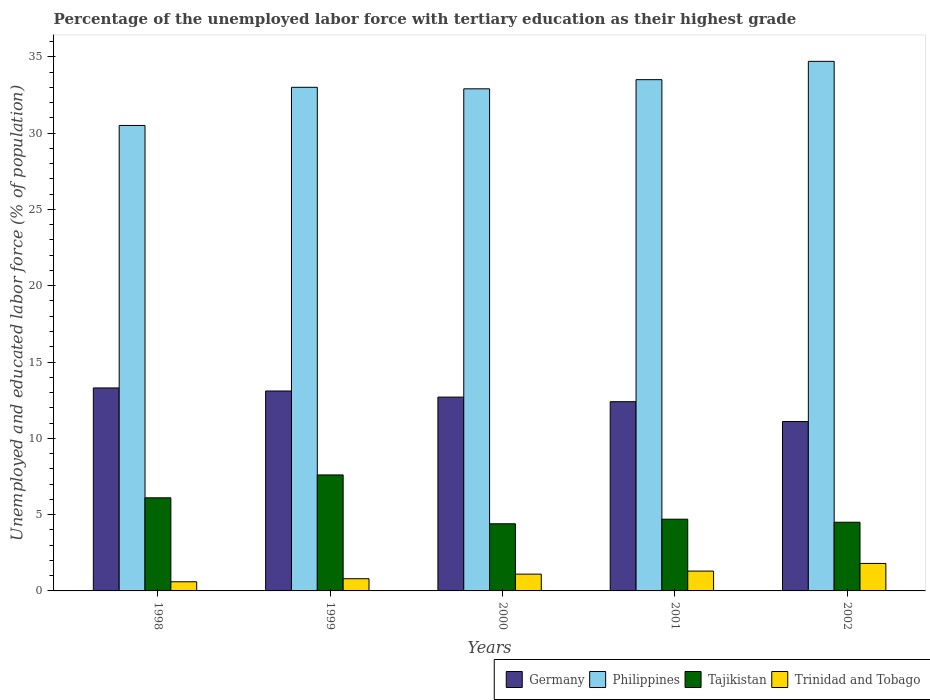How many different coloured bars are there?
Offer a very short reply. 4. How many groups of bars are there?
Your response must be concise. 5. How many bars are there on the 3rd tick from the left?
Provide a short and direct response. 4. What is the percentage of the unemployed labor force with tertiary education in Philippines in 2002?
Your response must be concise. 34.7. Across all years, what is the maximum percentage of the unemployed labor force with tertiary education in Trinidad and Tobago?
Offer a terse response. 1.8. Across all years, what is the minimum percentage of the unemployed labor force with tertiary education in Germany?
Offer a terse response. 11.1. In which year was the percentage of the unemployed labor force with tertiary education in Trinidad and Tobago maximum?
Keep it short and to the point. 2002. What is the total percentage of the unemployed labor force with tertiary education in Philippines in the graph?
Give a very brief answer. 164.6. What is the difference between the percentage of the unemployed labor force with tertiary education in Tajikistan in 1998 and that in 2002?
Give a very brief answer. 1.6. What is the difference between the percentage of the unemployed labor force with tertiary education in Philippines in 1998 and the percentage of the unemployed labor force with tertiary education in Germany in 1999?
Offer a very short reply. 17.4. What is the average percentage of the unemployed labor force with tertiary education in Philippines per year?
Your answer should be compact. 32.92. In the year 2000, what is the difference between the percentage of the unemployed labor force with tertiary education in Trinidad and Tobago and percentage of the unemployed labor force with tertiary education in Germany?
Give a very brief answer. -11.6. What is the ratio of the percentage of the unemployed labor force with tertiary education in Germany in 2001 to that in 2002?
Your response must be concise. 1.12. Is the percentage of the unemployed labor force with tertiary education in Philippines in 1998 less than that in 2001?
Give a very brief answer. Yes. Is the difference between the percentage of the unemployed labor force with tertiary education in Trinidad and Tobago in 1998 and 2001 greater than the difference between the percentage of the unemployed labor force with tertiary education in Germany in 1998 and 2001?
Your response must be concise. No. What is the difference between the highest and the second highest percentage of the unemployed labor force with tertiary education in Trinidad and Tobago?
Ensure brevity in your answer.  0.5. What is the difference between the highest and the lowest percentage of the unemployed labor force with tertiary education in Trinidad and Tobago?
Ensure brevity in your answer.  1.2. Is the sum of the percentage of the unemployed labor force with tertiary education in Germany in 2000 and 2002 greater than the maximum percentage of the unemployed labor force with tertiary education in Philippines across all years?
Offer a terse response. No. Is it the case that in every year, the sum of the percentage of the unemployed labor force with tertiary education in Germany and percentage of the unemployed labor force with tertiary education in Trinidad and Tobago is greater than the sum of percentage of the unemployed labor force with tertiary education in Philippines and percentage of the unemployed labor force with tertiary education in Tajikistan?
Give a very brief answer. No. What does the 1st bar from the left in 2000 represents?
Provide a short and direct response. Germany. What does the 2nd bar from the right in 2000 represents?
Give a very brief answer. Tajikistan. Is it the case that in every year, the sum of the percentage of the unemployed labor force with tertiary education in Germany and percentage of the unemployed labor force with tertiary education in Tajikistan is greater than the percentage of the unemployed labor force with tertiary education in Philippines?
Keep it short and to the point. No. How many years are there in the graph?
Keep it short and to the point. 5. What is the difference between two consecutive major ticks on the Y-axis?
Your answer should be very brief. 5. How many legend labels are there?
Provide a short and direct response. 4. What is the title of the graph?
Your response must be concise. Percentage of the unemployed labor force with tertiary education as their highest grade. Does "St. Martin (French part)" appear as one of the legend labels in the graph?
Ensure brevity in your answer.  No. What is the label or title of the Y-axis?
Offer a very short reply. Unemployed and educated labor force (% of population). What is the Unemployed and educated labor force (% of population) of Germany in 1998?
Give a very brief answer. 13.3. What is the Unemployed and educated labor force (% of population) in Philippines in 1998?
Offer a terse response. 30.5. What is the Unemployed and educated labor force (% of population) of Tajikistan in 1998?
Provide a short and direct response. 6.1. What is the Unemployed and educated labor force (% of population) of Trinidad and Tobago in 1998?
Provide a succinct answer. 0.6. What is the Unemployed and educated labor force (% of population) in Germany in 1999?
Ensure brevity in your answer.  13.1. What is the Unemployed and educated labor force (% of population) in Philippines in 1999?
Provide a short and direct response. 33. What is the Unemployed and educated labor force (% of population) in Tajikistan in 1999?
Give a very brief answer. 7.6. What is the Unemployed and educated labor force (% of population) in Trinidad and Tobago in 1999?
Ensure brevity in your answer.  0.8. What is the Unemployed and educated labor force (% of population) in Germany in 2000?
Your response must be concise. 12.7. What is the Unemployed and educated labor force (% of population) of Philippines in 2000?
Your response must be concise. 32.9. What is the Unemployed and educated labor force (% of population) of Tajikistan in 2000?
Provide a succinct answer. 4.4. What is the Unemployed and educated labor force (% of population) in Trinidad and Tobago in 2000?
Keep it short and to the point. 1.1. What is the Unemployed and educated labor force (% of population) of Germany in 2001?
Ensure brevity in your answer.  12.4. What is the Unemployed and educated labor force (% of population) of Philippines in 2001?
Give a very brief answer. 33.5. What is the Unemployed and educated labor force (% of population) in Tajikistan in 2001?
Keep it short and to the point. 4.7. What is the Unemployed and educated labor force (% of population) of Trinidad and Tobago in 2001?
Provide a short and direct response. 1.3. What is the Unemployed and educated labor force (% of population) in Germany in 2002?
Your answer should be compact. 11.1. What is the Unemployed and educated labor force (% of population) in Philippines in 2002?
Your response must be concise. 34.7. What is the Unemployed and educated labor force (% of population) of Tajikistan in 2002?
Keep it short and to the point. 4.5. What is the Unemployed and educated labor force (% of population) in Trinidad and Tobago in 2002?
Offer a very short reply. 1.8. Across all years, what is the maximum Unemployed and educated labor force (% of population) of Germany?
Provide a short and direct response. 13.3. Across all years, what is the maximum Unemployed and educated labor force (% of population) in Philippines?
Make the answer very short. 34.7. Across all years, what is the maximum Unemployed and educated labor force (% of population) in Tajikistan?
Offer a very short reply. 7.6. Across all years, what is the maximum Unemployed and educated labor force (% of population) in Trinidad and Tobago?
Offer a terse response. 1.8. Across all years, what is the minimum Unemployed and educated labor force (% of population) of Germany?
Your answer should be compact. 11.1. Across all years, what is the minimum Unemployed and educated labor force (% of population) of Philippines?
Offer a terse response. 30.5. Across all years, what is the minimum Unemployed and educated labor force (% of population) of Tajikistan?
Ensure brevity in your answer.  4.4. Across all years, what is the minimum Unemployed and educated labor force (% of population) of Trinidad and Tobago?
Offer a terse response. 0.6. What is the total Unemployed and educated labor force (% of population) of Germany in the graph?
Your answer should be very brief. 62.6. What is the total Unemployed and educated labor force (% of population) in Philippines in the graph?
Your answer should be very brief. 164.6. What is the total Unemployed and educated labor force (% of population) of Tajikistan in the graph?
Offer a terse response. 27.3. What is the total Unemployed and educated labor force (% of population) of Trinidad and Tobago in the graph?
Offer a very short reply. 5.6. What is the difference between the Unemployed and educated labor force (% of population) of Philippines in 1998 and that in 1999?
Your answer should be compact. -2.5. What is the difference between the Unemployed and educated labor force (% of population) of Trinidad and Tobago in 1998 and that in 1999?
Give a very brief answer. -0.2. What is the difference between the Unemployed and educated labor force (% of population) in Germany in 1998 and that in 2000?
Provide a short and direct response. 0.6. What is the difference between the Unemployed and educated labor force (% of population) of Philippines in 1998 and that in 2000?
Your answer should be very brief. -2.4. What is the difference between the Unemployed and educated labor force (% of population) in Trinidad and Tobago in 1998 and that in 2000?
Give a very brief answer. -0.5. What is the difference between the Unemployed and educated labor force (% of population) of Philippines in 1998 and that in 2001?
Ensure brevity in your answer.  -3. What is the difference between the Unemployed and educated labor force (% of population) in Germany in 1998 and that in 2002?
Keep it short and to the point. 2.2. What is the difference between the Unemployed and educated labor force (% of population) of Philippines in 1998 and that in 2002?
Your response must be concise. -4.2. What is the difference between the Unemployed and educated labor force (% of population) of Tajikistan in 1998 and that in 2002?
Offer a terse response. 1.6. What is the difference between the Unemployed and educated labor force (% of population) of Philippines in 1999 and that in 2000?
Provide a succinct answer. 0.1. What is the difference between the Unemployed and educated labor force (% of population) of Tajikistan in 1999 and that in 2000?
Make the answer very short. 3.2. What is the difference between the Unemployed and educated labor force (% of population) in Trinidad and Tobago in 1999 and that in 2000?
Provide a short and direct response. -0.3. What is the difference between the Unemployed and educated labor force (% of population) of Trinidad and Tobago in 1999 and that in 2001?
Ensure brevity in your answer.  -0.5. What is the difference between the Unemployed and educated labor force (% of population) of Tajikistan in 1999 and that in 2002?
Your answer should be compact. 3.1. What is the difference between the Unemployed and educated labor force (% of population) in Germany in 2000 and that in 2001?
Offer a very short reply. 0.3. What is the difference between the Unemployed and educated labor force (% of population) of Tajikistan in 2000 and that in 2001?
Give a very brief answer. -0.3. What is the difference between the Unemployed and educated labor force (% of population) in Philippines in 2000 and that in 2002?
Your response must be concise. -1.8. What is the difference between the Unemployed and educated labor force (% of population) of Tajikistan in 2000 and that in 2002?
Your response must be concise. -0.1. What is the difference between the Unemployed and educated labor force (% of population) of Germany in 2001 and that in 2002?
Provide a succinct answer. 1.3. What is the difference between the Unemployed and educated labor force (% of population) in Philippines in 2001 and that in 2002?
Make the answer very short. -1.2. What is the difference between the Unemployed and educated labor force (% of population) in Germany in 1998 and the Unemployed and educated labor force (% of population) in Philippines in 1999?
Offer a terse response. -19.7. What is the difference between the Unemployed and educated labor force (% of population) of Philippines in 1998 and the Unemployed and educated labor force (% of population) of Tajikistan in 1999?
Give a very brief answer. 22.9. What is the difference between the Unemployed and educated labor force (% of population) in Philippines in 1998 and the Unemployed and educated labor force (% of population) in Trinidad and Tobago in 1999?
Make the answer very short. 29.7. What is the difference between the Unemployed and educated labor force (% of population) in Germany in 1998 and the Unemployed and educated labor force (% of population) in Philippines in 2000?
Ensure brevity in your answer.  -19.6. What is the difference between the Unemployed and educated labor force (% of population) in Germany in 1998 and the Unemployed and educated labor force (% of population) in Tajikistan in 2000?
Your response must be concise. 8.9. What is the difference between the Unemployed and educated labor force (% of population) in Philippines in 1998 and the Unemployed and educated labor force (% of population) in Tajikistan in 2000?
Offer a very short reply. 26.1. What is the difference between the Unemployed and educated labor force (% of population) of Philippines in 1998 and the Unemployed and educated labor force (% of population) of Trinidad and Tobago in 2000?
Provide a short and direct response. 29.4. What is the difference between the Unemployed and educated labor force (% of population) in Tajikistan in 1998 and the Unemployed and educated labor force (% of population) in Trinidad and Tobago in 2000?
Offer a terse response. 5. What is the difference between the Unemployed and educated labor force (% of population) in Germany in 1998 and the Unemployed and educated labor force (% of population) in Philippines in 2001?
Your response must be concise. -20.2. What is the difference between the Unemployed and educated labor force (% of population) of Germany in 1998 and the Unemployed and educated labor force (% of population) of Tajikistan in 2001?
Give a very brief answer. 8.6. What is the difference between the Unemployed and educated labor force (% of population) of Germany in 1998 and the Unemployed and educated labor force (% of population) of Trinidad and Tobago in 2001?
Make the answer very short. 12. What is the difference between the Unemployed and educated labor force (% of population) of Philippines in 1998 and the Unemployed and educated labor force (% of population) of Tajikistan in 2001?
Offer a terse response. 25.8. What is the difference between the Unemployed and educated labor force (% of population) in Philippines in 1998 and the Unemployed and educated labor force (% of population) in Trinidad and Tobago in 2001?
Keep it short and to the point. 29.2. What is the difference between the Unemployed and educated labor force (% of population) in Germany in 1998 and the Unemployed and educated labor force (% of population) in Philippines in 2002?
Provide a succinct answer. -21.4. What is the difference between the Unemployed and educated labor force (% of population) in Germany in 1998 and the Unemployed and educated labor force (% of population) in Tajikistan in 2002?
Offer a terse response. 8.8. What is the difference between the Unemployed and educated labor force (% of population) in Germany in 1998 and the Unemployed and educated labor force (% of population) in Trinidad and Tobago in 2002?
Offer a very short reply. 11.5. What is the difference between the Unemployed and educated labor force (% of population) of Philippines in 1998 and the Unemployed and educated labor force (% of population) of Trinidad and Tobago in 2002?
Keep it short and to the point. 28.7. What is the difference between the Unemployed and educated labor force (% of population) of Tajikistan in 1998 and the Unemployed and educated labor force (% of population) of Trinidad and Tobago in 2002?
Offer a terse response. 4.3. What is the difference between the Unemployed and educated labor force (% of population) of Germany in 1999 and the Unemployed and educated labor force (% of population) of Philippines in 2000?
Your response must be concise. -19.8. What is the difference between the Unemployed and educated labor force (% of population) in Germany in 1999 and the Unemployed and educated labor force (% of population) in Tajikistan in 2000?
Make the answer very short. 8.7. What is the difference between the Unemployed and educated labor force (% of population) in Germany in 1999 and the Unemployed and educated labor force (% of population) in Trinidad and Tobago in 2000?
Provide a short and direct response. 12. What is the difference between the Unemployed and educated labor force (% of population) in Philippines in 1999 and the Unemployed and educated labor force (% of population) in Tajikistan in 2000?
Your answer should be compact. 28.6. What is the difference between the Unemployed and educated labor force (% of population) in Philippines in 1999 and the Unemployed and educated labor force (% of population) in Trinidad and Tobago in 2000?
Keep it short and to the point. 31.9. What is the difference between the Unemployed and educated labor force (% of population) in Tajikistan in 1999 and the Unemployed and educated labor force (% of population) in Trinidad and Tobago in 2000?
Make the answer very short. 6.5. What is the difference between the Unemployed and educated labor force (% of population) of Germany in 1999 and the Unemployed and educated labor force (% of population) of Philippines in 2001?
Keep it short and to the point. -20.4. What is the difference between the Unemployed and educated labor force (% of population) in Germany in 1999 and the Unemployed and educated labor force (% of population) in Trinidad and Tobago in 2001?
Make the answer very short. 11.8. What is the difference between the Unemployed and educated labor force (% of population) in Philippines in 1999 and the Unemployed and educated labor force (% of population) in Tajikistan in 2001?
Your answer should be very brief. 28.3. What is the difference between the Unemployed and educated labor force (% of population) in Philippines in 1999 and the Unemployed and educated labor force (% of population) in Trinidad and Tobago in 2001?
Offer a terse response. 31.7. What is the difference between the Unemployed and educated labor force (% of population) of Germany in 1999 and the Unemployed and educated labor force (% of population) of Philippines in 2002?
Give a very brief answer. -21.6. What is the difference between the Unemployed and educated labor force (% of population) of Germany in 1999 and the Unemployed and educated labor force (% of population) of Tajikistan in 2002?
Offer a terse response. 8.6. What is the difference between the Unemployed and educated labor force (% of population) in Philippines in 1999 and the Unemployed and educated labor force (% of population) in Trinidad and Tobago in 2002?
Provide a short and direct response. 31.2. What is the difference between the Unemployed and educated labor force (% of population) in Tajikistan in 1999 and the Unemployed and educated labor force (% of population) in Trinidad and Tobago in 2002?
Offer a terse response. 5.8. What is the difference between the Unemployed and educated labor force (% of population) of Germany in 2000 and the Unemployed and educated labor force (% of population) of Philippines in 2001?
Make the answer very short. -20.8. What is the difference between the Unemployed and educated labor force (% of population) of Germany in 2000 and the Unemployed and educated labor force (% of population) of Trinidad and Tobago in 2001?
Your answer should be compact. 11.4. What is the difference between the Unemployed and educated labor force (% of population) in Philippines in 2000 and the Unemployed and educated labor force (% of population) in Tajikistan in 2001?
Make the answer very short. 28.2. What is the difference between the Unemployed and educated labor force (% of population) in Philippines in 2000 and the Unemployed and educated labor force (% of population) in Trinidad and Tobago in 2001?
Provide a short and direct response. 31.6. What is the difference between the Unemployed and educated labor force (% of population) in Tajikistan in 2000 and the Unemployed and educated labor force (% of population) in Trinidad and Tobago in 2001?
Offer a very short reply. 3.1. What is the difference between the Unemployed and educated labor force (% of population) of Germany in 2000 and the Unemployed and educated labor force (% of population) of Tajikistan in 2002?
Offer a very short reply. 8.2. What is the difference between the Unemployed and educated labor force (% of population) of Philippines in 2000 and the Unemployed and educated labor force (% of population) of Tajikistan in 2002?
Keep it short and to the point. 28.4. What is the difference between the Unemployed and educated labor force (% of population) of Philippines in 2000 and the Unemployed and educated labor force (% of population) of Trinidad and Tobago in 2002?
Give a very brief answer. 31.1. What is the difference between the Unemployed and educated labor force (% of population) in Germany in 2001 and the Unemployed and educated labor force (% of population) in Philippines in 2002?
Your response must be concise. -22.3. What is the difference between the Unemployed and educated labor force (% of population) of Germany in 2001 and the Unemployed and educated labor force (% of population) of Tajikistan in 2002?
Provide a succinct answer. 7.9. What is the difference between the Unemployed and educated labor force (% of population) of Germany in 2001 and the Unemployed and educated labor force (% of population) of Trinidad and Tobago in 2002?
Give a very brief answer. 10.6. What is the difference between the Unemployed and educated labor force (% of population) in Philippines in 2001 and the Unemployed and educated labor force (% of population) in Trinidad and Tobago in 2002?
Your response must be concise. 31.7. What is the difference between the Unemployed and educated labor force (% of population) in Tajikistan in 2001 and the Unemployed and educated labor force (% of population) in Trinidad and Tobago in 2002?
Keep it short and to the point. 2.9. What is the average Unemployed and educated labor force (% of population) of Germany per year?
Offer a very short reply. 12.52. What is the average Unemployed and educated labor force (% of population) in Philippines per year?
Provide a short and direct response. 32.92. What is the average Unemployed and educated labor force (% of population) of Tajikistan per year?
Keep it short and to the point. 5.46. What is the average Unemployed and educated labor force (% of population) in Trinidad and Tobago per year?
Make the answer very short. 1.12. In the year 1998, what is the difference between the Unemployed and educated labor force (% of population) of Germany and Unemployed and educated labor force (% of population) of Philippines?
Keep it short and to the point. -17.2. In the year 1998, what is the difference between the Unemployed and educated labor force (% of population) in Germany and Unemployed and educated labor force (% of population) in Trinidad and Tobago?
Provide a succinct answer. 12.7. In the year 1998, what is the difference between the Unemployed and educated labor force (% of population) of Philippines and Unemployed and educated labor force (% of population) of Tajikistan?
Provide a succinct answer. 24.4. In the year 1998, what is the difference between the Unemployed and educated labor force (% of population) of Philippines and Unemployed and educated labor force (% of population) of Trinidad and Tobago?
Offer a very short reply. 29.9. In the year 1998, what is the difference between the Unemployed and educated labor force (% of population) in Tajikistan and Unemployed and educated labor force (% of population) in Trinidad and Tobago?
Keep it short and to the point. 5.5. In the year 1999, what is the difference between the Unemployed and educated labor force (% of population) of Germany and Unemployed and educated labor force (% of population) of Philippines?
Your answer should be very brief. -19.9. In the year 1999, what is the difference between the Unemployed and educated labor force (% of population) in Germany and Unemployed and educated labor force (% of population) in Tajikistan?
Give a very brief answer. 5.5. In the year 1999, what is the difference between the Unemployed and educated labor force (% of population) of Philippines and Unemployed and educated labor force (% of population) of Tajikistan?
Your answer should be compact. 25.4. In the year 1999, what is the difference between the Unemployed and educated labor force (% of population) in Philippines and Unemployed and educated labor force (% of population) in Trinidad and Tobago?
Provide a short and direct response. 32.2. In the year 2000, what is the difference between the Unemployed and educated labor force (% of population) of Germany and Unemployed and educated labor force (% of population) of Philippines?
Offer a terse response. -20.2. In the year 2000, what is the difference between the Unemployed and educated labor force (% of population) in Germany and Unemployed and educated labor force (% of population) in Tajikistan?
Your answer should be very brief. 8.3. In the year 2000, what is the difference between the Unemployed and educated labor force (% of population) of Philippines and Unemployed and educated labor force (% of population) of Trinidad and Tobago?
Give a very brief answer. 31.8. In the year 2001, what is the difference between the Unemployed and educated labor force (% of population) of Germany and Unemployed and educated labor force (% of population) of Philippines?
Ensure brevity in your answer.  -21.1. In the year 2001, what is the difference between the Unemployed and educated labor force (% of population) in Philippines and Unemployed and educated labor force (% of population) in Tajikistan?
Your answer should be very brief. 28.8. In the year 2001, what is the difference between the Unemployed and educated labor force (% of population) of Philippines and Unemployed and educated labor force (% of population) of Trinidad and Tobago?
Your response must be concise. 32.2. In the year 2002, what is the difference between the Unemployed and educated labor force (% of population) of Germany and Unemployed and educated labor force (% of population) of Philippines?
Your answer should be compact. -23.6. In the year 2002, what is the difference between the Unemployed and educated labor force (% of population) of Germany and Unemployed and educated labor force (% of population) of Tajikistan?
Provide a short and direct response. 6.6. In the year 2002, what is the difference between the Unemployed and educated labor force (% of population) of Germany and Unemployed and educated labor force (% of population) of Trinidad and Tobago?
Ensure brevity in your answer.  9.3. In the year 2002, what is the difference between the Unemployed and educated labor force (% of population) of Philippines and Unemployed and educated labor force (% of population) of Tajikistan?
Provide a succinct answer. 30.2. In the year 2002, what is the difference between the Unemployed and educated labor force (% of population) of Philippines and Unemployed and educated labor force (% of population) of Trinidad and Tobago?
Your response must be concise. 32.9. In the year 2002, what is the difference between the Unemployed and educated labor force (% of population) of Tajikistan and Unemployed and educated labor force (% of population) of Trinidad and Tobago?
Make the answer very short. 2.7. What is the ratio of the Unemployed and educated labor force (% of population) of Germany in 1998 to that in 1999?
Give a very brief answer. 1.02. What is the ratio of the Unemployed and educated labor force (% of population) in Philippines in 1998 to that in 1999?
Make the answer very short. 0.92. What is the ratio of the Unemployed and educated labor force (% of population) of Tajikistan in 1998 to that in 1999?
Keep it short and to the point. 0.8. What is the ratio of the Unemployed and educated labor force (% of population) of Germany in 1998 to that in 2000?
Your answer should be compact. 1.05. What is the ratio of the Unemployed and educated labor force (% of population) of Philippines in 1998 to that in 2000?
Provide a short and direct response. 0.93. What is the ratio of the Unemployed and educated labor force (% of population) in Tajikistan in 1998 to that in 2000?
Make the answer very short. 1.39. What is the ratio of the Unemployed and educated labor force (% of population) of Trinidad and Tobago in 1998 to that in 2000?
Provide a short and direct response. 0.55. What is the ratio of the Unemployed and educated labor force (% of population) in Germany in 1998 to that in 2001?
Make the answer very short. 1.07. What is the ratio of the Unemployed and educated labor force (% of population) in Philippines in 1998 to that in 2001?
Your answer should be compact. 0.91. What is the ratio of the Unemployed and educated labor force (% of population) of Tajikistan in 1998 to that in 2001?
Make the answer very short. 1.3. What is the ratio of the Unemployed and educated labor force (% of population) in Trinidad and Tobago in 1998 to that in 2001?
Your answer should be compact. 0.46. What is the ratio of the Unemployed and educated labor force (% of population) in Germany in 1998 to that in 2002?
Give a very brief answer. 1.2. What is the ratio of the Unemployed and educated labor force (% of population) in Philippines in 1998 to that in 2002?
Your answer should be compact. 0.88. What is the ratio of the Unemployed and educated labor force (% of population) of Tajikistan in 1998 to that in 2002?
Offer a terse response. 1.36. What is the ratio of the Unemployed and educated labor force (% of population) in Trinidad and Tobago in 1998 to that in 2002?
Your response must be concise. 0.33. What is the ratio of the Unemployed and educated labor force (% of population) of Germany in 1999 to that in 2000?
Keep it short and to the point. 1.03. What is the ratio of the Unemployed and educated labor force (% of population) in Philippines in 1999 to that in 2000?
Offer a terse response. 1. What is the ratio of the Unemployed and educated labor force (% of population) of Tajikistan in 1999 to that in 2000?
Ensure brevity in your answer.  1.73. What is the ratio of the Unemployed and educated labor force (% of population) of Trinidad and Tobago in 1999 to that in 2000?
Offer a terse response. 0.73. What is the ratio of the Unemployed and educated labor force (% of population) of Germany in 1999 to that in 2001?
Keep it short and to the point. 1.06. What is the ratio of the Unemployed and educated labor force (% of population) of Philippines in 1999 to that in 2001?
Give a very brief answer. 0.99. What is the ratio of the Unemployed and educated labor force (% of population) in Tajikistan in 1999 to that in 2001?
Ensure brevity in your answer.  1.62. What is the ratio of the Unemployed and educated labor force (% of population) of Trinidad and Tobago in 1999 to that in 2001?
Make the answer very short. 0.62. What is the ratio of the Unemployed and educated labor force (% of population) of Germany in 1999 to that in 2002?
Offer a very short reply. 1.18. What is the ratio of the Unemployed and educated labor force (% of population) in Philippines in 1999 to that in 2002?
Offer a terse response. 0.95. What is the ratio of the Unemployed and educated labor force (% of population) of Tajikistan in 1999 to that in 2002?
Offer a terse response. 1.69. What is the ratio of the Unemployed and educated labor force (% of population) of Trinidad and Tobago in 1999 to that in 2002?
Provide a short and direct response. 0.44. What is the ratio of the Unemployed and educated labor force (% of population) in Germany in 2000 to that in 2001?
Give a very brief answer. 1.02. What is the ratio of the Unemployed and educated labor force (% of population) of Philippines in 2000 to that in 2001?
Offer a terse response. 0.98. What is the ratio of the Unemployed and educated labor force (% of population) in Tajikistan in 2000 to that in 2001?
Provide a short and direct response. 0.94. What is the ratio of the Unemployed and educated labor force (% of population) in Trinidad and Tobago in 2000 to that in 2001?
Offer a very short reply. 0.85. What is the ratio of the Unemployed and educated labor force (% of population) of Germany in 2000 to that in 2002?
Provide a succinct answer. 1.14. What is the ratio of the Unemployed and educated labor force (% of population) of Philippines in 2000 to that in 2002?
Provide a short and direct response. 0.95. What is the ratio of the Unemployed and educated labor force (% of population) of Tajikistan in 2000 to that in 2002?
Provide a succinct answer. 0.98. What is the ratio of the Unemployed and educated labor force (% of population) in Trinidad and Tobago in 2000 to that in 2002?
Provide a succinct answer. 0.61. What is the ratio of the Unemployed and educated labor force (% of population) of Germany in 2001 to that in 2002?
Provide a succinct answer. 1.12. What is the ratio of the Unemployed and educated labor force (% of population) of Philippines in 2001 to that in 2002?
Your answer should be very brief. 0.97. What is the ratio of the Unemployed and educated labor force (% of population) of Tajikistan in 2001 to that in 2002?
Provide a short and direct response. 1.04. What is the ratio of the Unemployed and educated labor force (% of population) of Trinidad and Tobago in 2001 to that in 2002?
Make the answer very short. 0.72. What is the difference between the highest and the second highest Unemployed and educated labor force (% of population) in Trinidad and Tobago?
Your answer should be compact. 0.5. What is the difference between the highest and the lowest Unemployed and educated labor force (% of population) of Philippines?
Give a very brief answer. 4.2. What is the difference between the highest and the lowest Unemployed and educated labor force (% of population) of Tajikistan?
Provide a succinct answer. 3.2. 